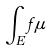<formula> <loc_0><loc_0><loc_500><loc_500>\int _ { E } f \mu</formula> 